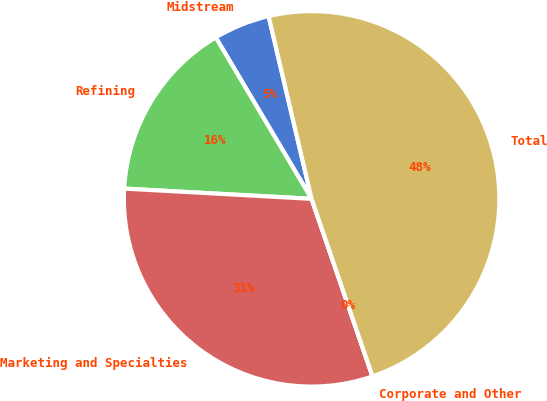Convert chart. <chart><loc_0><loc_0><loc_500><loc_500><pie_chart><fcel>Midstream<fcel>Refining<fcel>Marketing and Specialties<fcel>Corporate and Other<fcel>Total<nl><fcel>4.85%<fcel>15.6%<fcel>31.13%<fcel>0.0%<fcel>48.42%<nl></chart> 